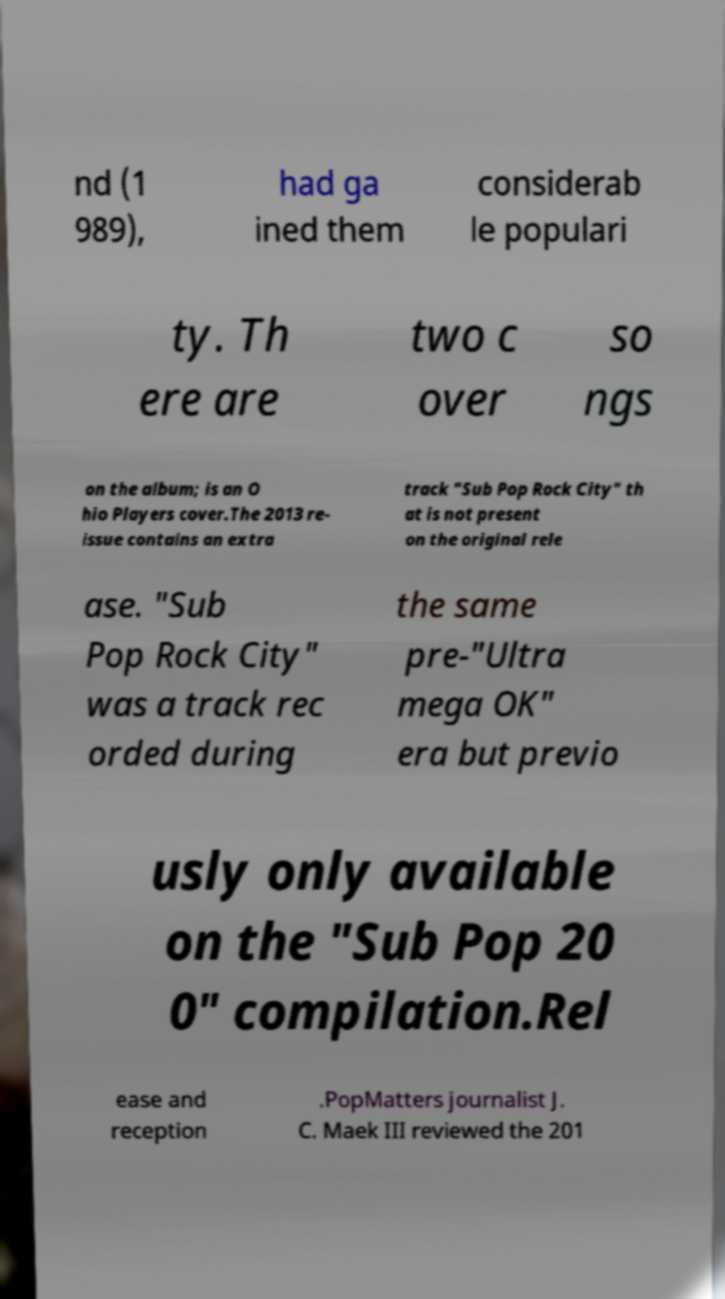I need the written content from this picture converted into text. Can you do that? nd (1 989), had ga ined them considerab le populari ty. Th ere are two c over so ngs on the album; is an O hio Players cover.The 2013 re- issue contains an extra track "Sub Pop Rock City" th at is not present on the original rele ase. "Sub Pop Rock City" was a track rec orded during the same pre-"Ultra mega OK" era but previo usly only available on the "Sub Pop 20 0" compilation.Rel ease and reception .PopMatters journalist J. C. Maek III reviewed the 201 